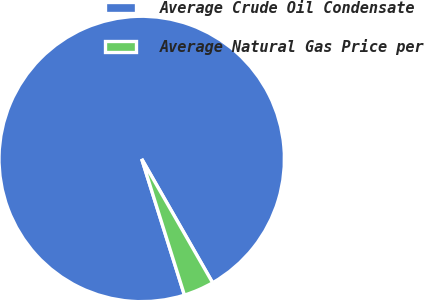Convert chart. <chart><loc_0><loc_0><loc_500><loc_500><pie_chart><fcel>Average Crude Oil Condensate<fcel>Average Natural Gas Price per<nl><fcel>96.56%<fcel>3.44%<nl></chart> 